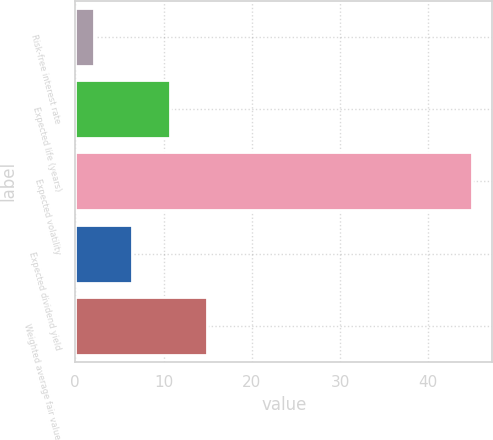Convert chart to OTSL. <chart><loc_0><loc_0><loc_500><loc_500><bar_chart><fcel>Risk-free interest rate<fcel>Expected life (years)<fcel>Expected volatility<fcel>Expected dividend yield<fcel>Weighted average fair value<nl><fcel>2.1<fcel>10.68<fcel>45<fcel>6.39<fcel>14.97<nl></chart> 